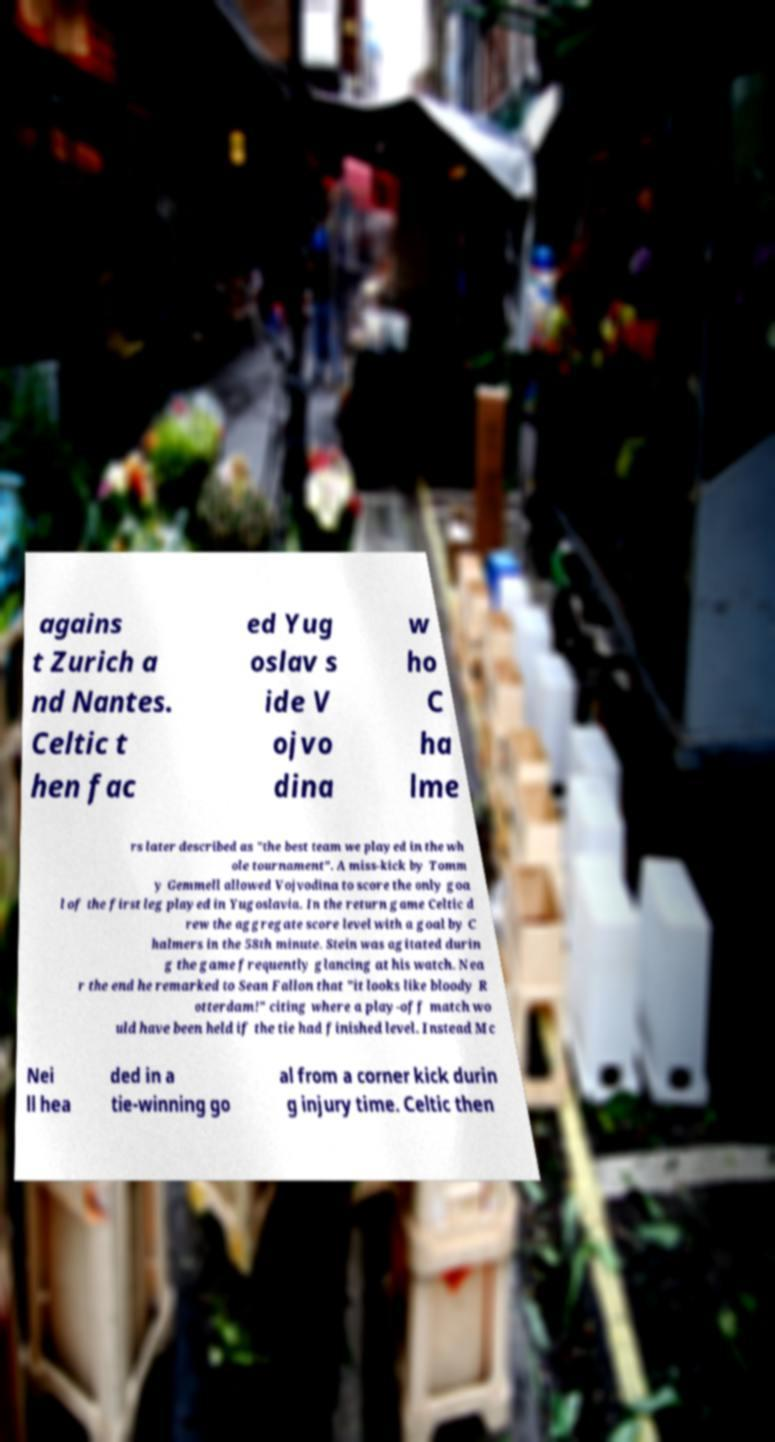Can you accurately transcribe the text from the provided image for me? agains t Zurich a nd Nantes. Celtic t hen fac ed Yug oslav s ide V ojvo dina w ho C ha lme rs later described as "the best team we played in the wh ole tournament". A miss-kick by Tomm y Gemmell allowed Vojvodina to score the only goa l of the first leg played in Yugoslavia. In the return game Celtic d rew the aggregate score level with a goal by C halmers in the 58th minute. Stein was agitated durin g the game frequently glancing at his watch. Nea r the end he remarked to Sean Fallon that "it looks like bloody R otterdam!" citing where a play-off match wo uld have been held if the tie had finished level. Instead Mc Nei ll hea ded in a tie-winning go al from a corner kick durin g injury time. Celtic then 